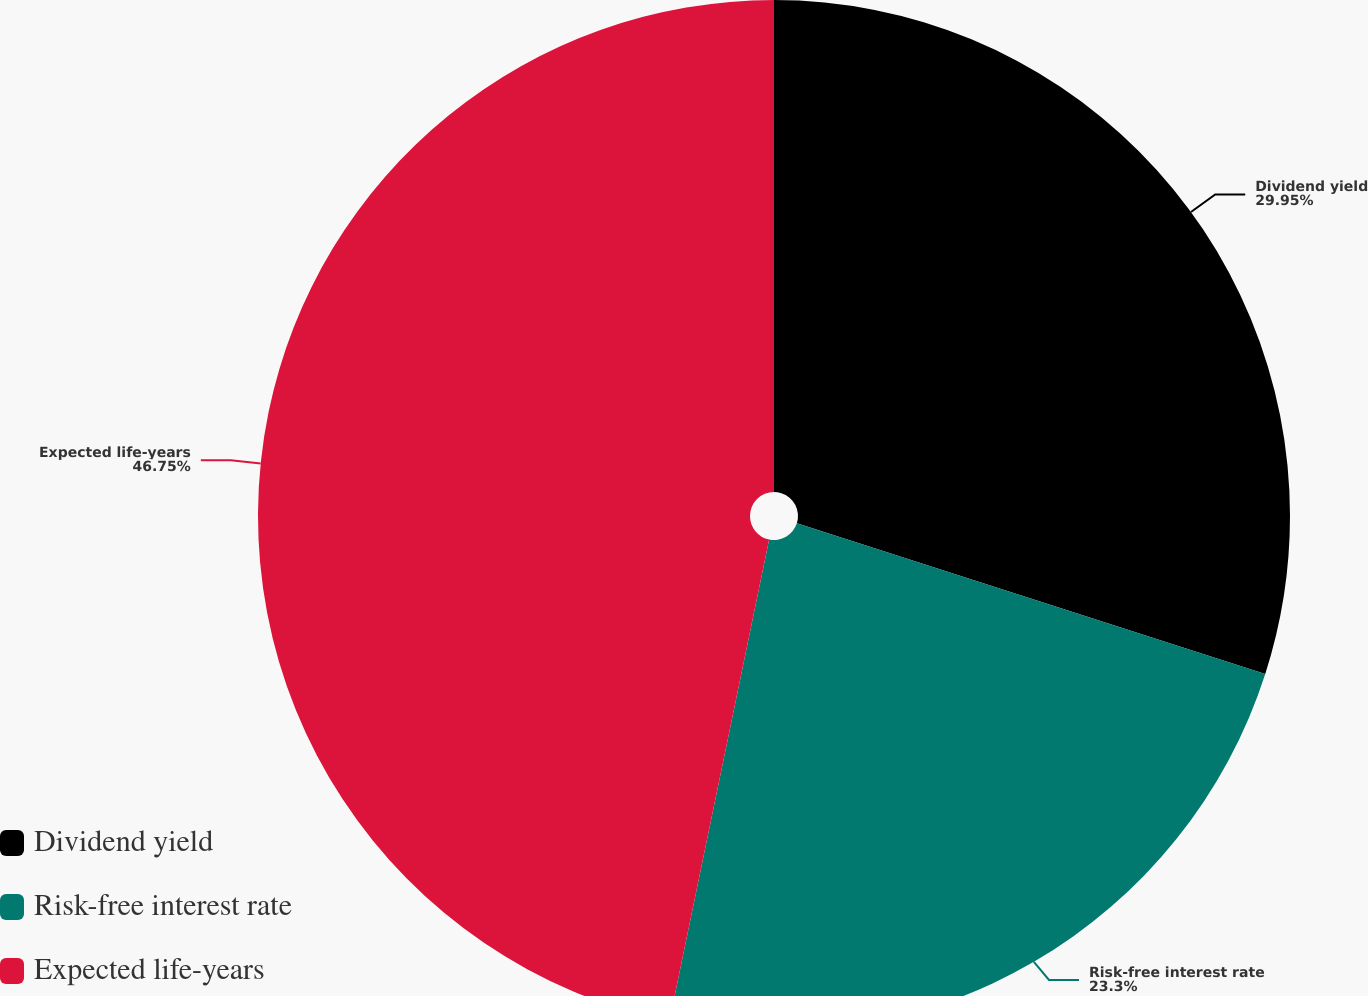<chart> <loc_0><loc_0><loc_500><loc_500><pie_chart><fcel>Dividend yield<fcel>Risk-free interest rate<fcel>Expected life-years<nl><fcel>29.95%<fcel>23.3%<fcel>46.75%<nl></chart> 